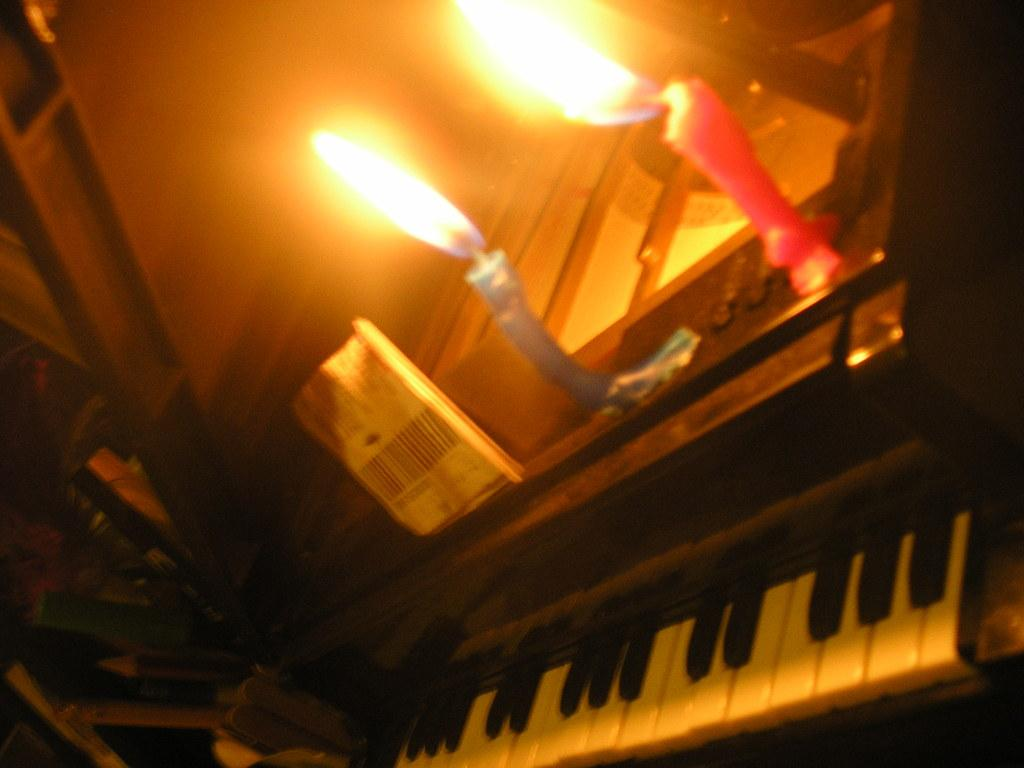What is the main object in the image? There is a piano in the image. Are there any additional objects placed on the piano? Yes, there are two candles placed on the piano. What type of lumber is being used to fuel the oven in the image? There is no lumber or oven present in the image; it features a piano with two candles on it. What kind of shoes are visible on the floor near the piano? There is no mention of shoes in the image; it only features a piano and two candles. 